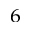<formula> <loc_0><loc_0><loc_500><loc_500>^ { 6 }</formula> 